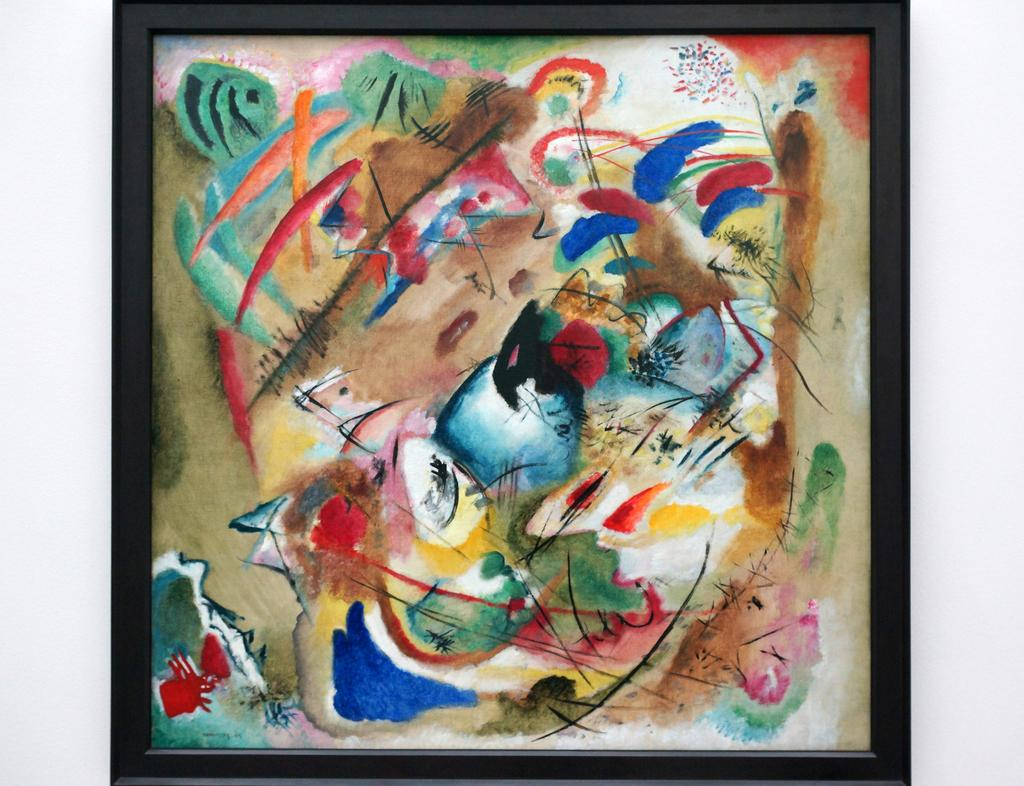What type of artwork is depicted in the image? There is an abstract painting in the image. How is the abstract painting displayed? The abstract painting is on a photo frame. What is the opinion of the trees about the abstract painting in the image? There are no trees present in the image, so it is not possible to determine their opinion about the abstract painting. 